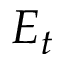Convert formula to latex. <formula><loc_0><loc_0><loc_500><loc_500>E _ { t }</formula> 